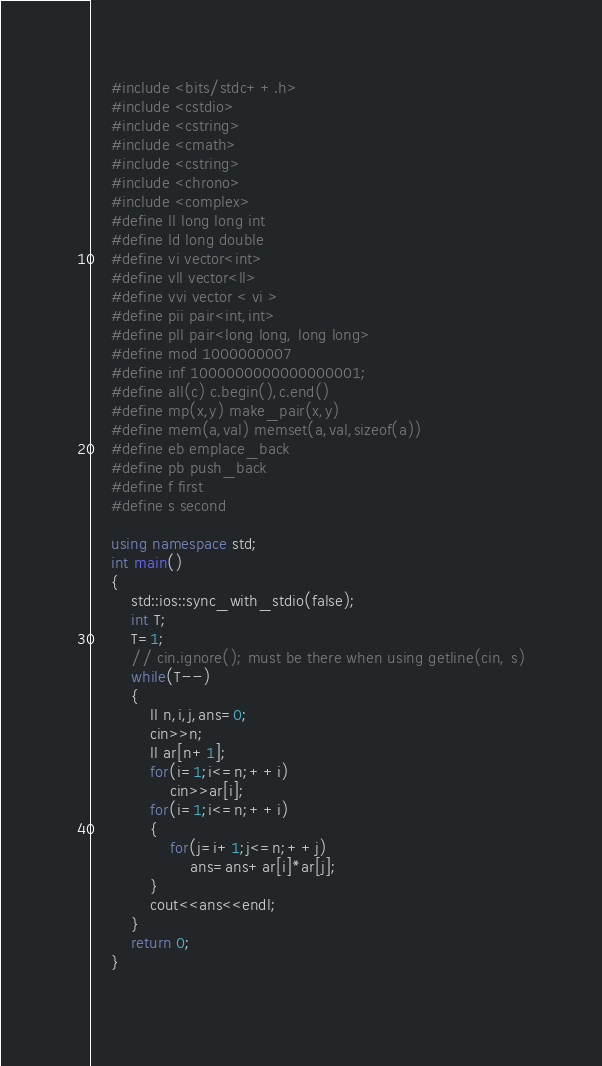<code> <loc_0><loc_0><loc_500><loc_500><_C++_>
    #include <bits/stdc++.h>
    #include <cstdio>
    #include <cstring>
    #include <cmath>
    #include <cstring>
    #include <chrono>
    #include <complex>
    #define ll long long int
    #define ld long double
    #define vi vector<int>
    #define vll vector<ll>
    #define vvi vector < vi >
    #define pii pair<int,int>
    #define pll pair<long long, long long>
    #define mod 1000000007
    #define inf 1000000000000000001;
    #define all(c) c.begin(),c.end()
    #define mp(x,y) make_pair(x,y)
    #define mem(a,val) memset(a,val,sizeof(a))
    #define eb emplace_back
    #define pb push_back
    #define f first
    #define s second
    
    using namespace std;
    int main()
    {
        std::ios::sync_with_stdio(false);
        int T;
        T=1;
        // cin.ignore(); must be there when using getline(cin, s)
        while(T--)
        {
            ll n,i,j,ans=0;
            cin>>n;
            ll ar[n+1];
            for(i=1;i<=n;++i)
                cin>>ar[i];
            for(i=1;i<=n;++i)
            {
                for(j=i+1;j<=n;++j)
                    ans=ans+ar[i]*ar[j];
            }
            cout<<ans<<endl;
        }
        return 0;
    }
	</code> 